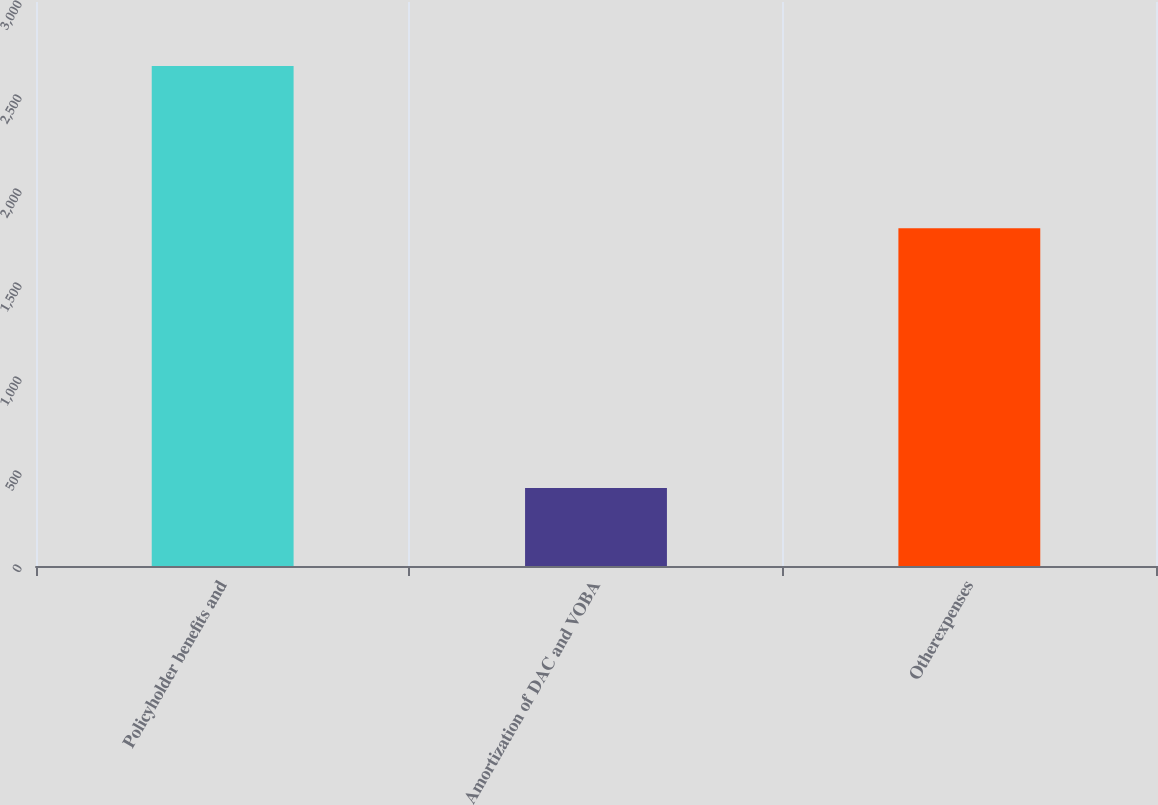<chart> <loc_0><loc_0><loc_500><loc_500><bar_chart><fcel>Policyholder benefits and<fcel>Amortization of DAC and VOBA<fcel>Otherexpenses<nl><fcel>2660<fcel>415<fcel>1797<nl></chart> 